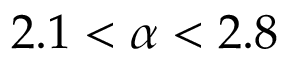<formula> <loc_0><loc_0><loc_500><loc_500>2 . 1 < \alpha < 2 . 8</formula> 